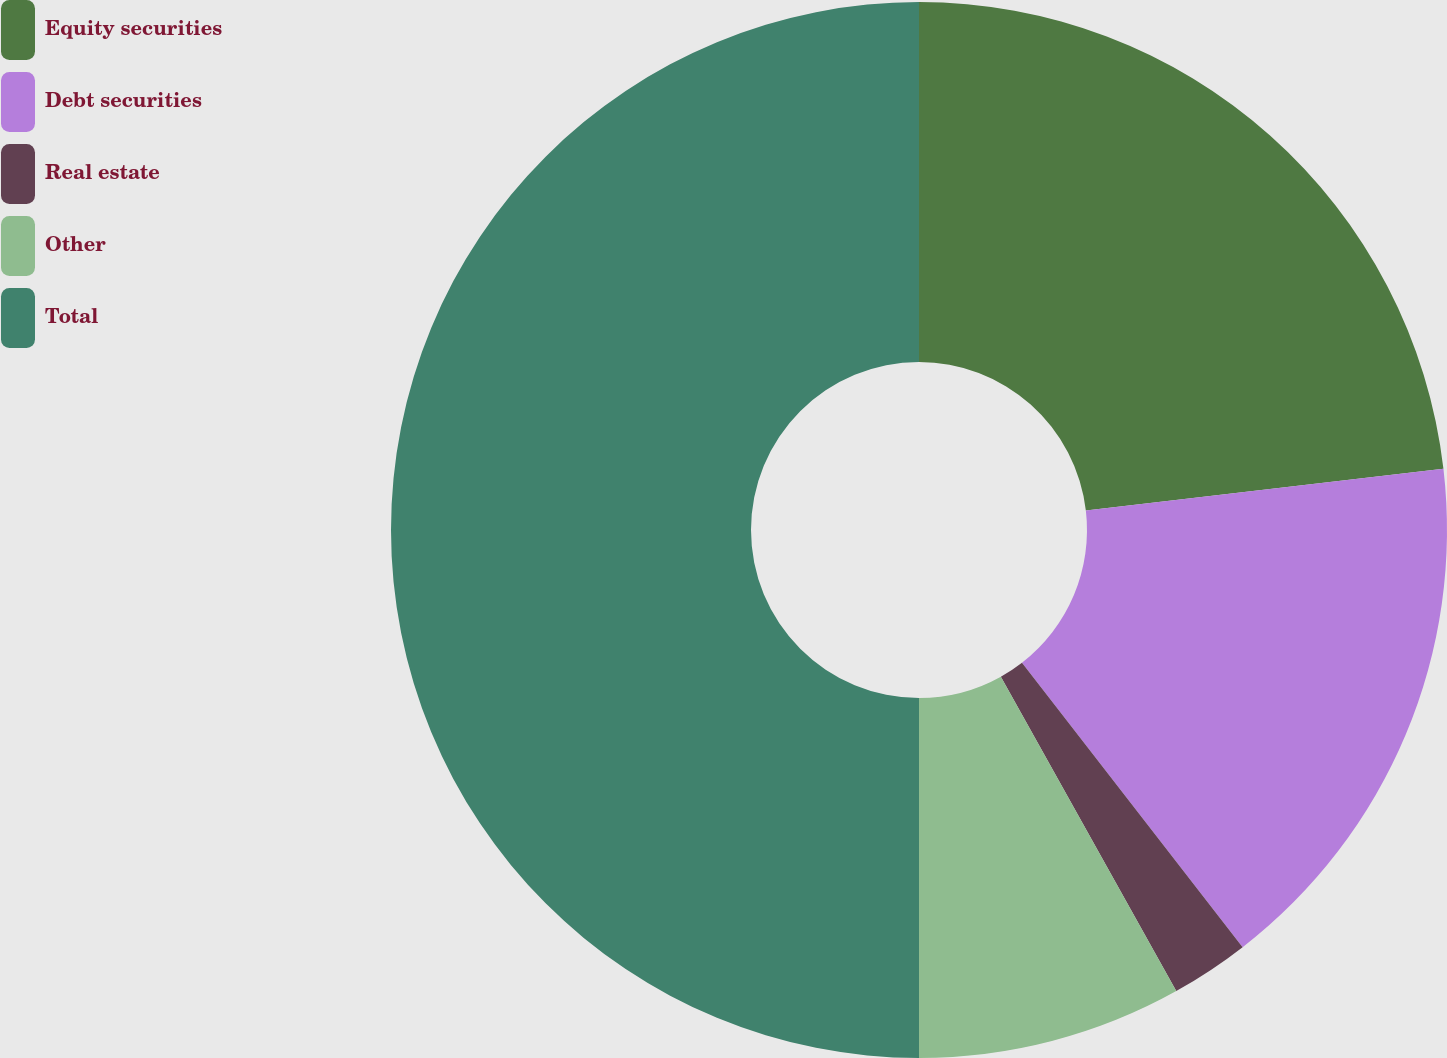Convert chart to OTSL. <chart><loc_0><loc_0><loc_500><loc_500><pie_chart><fcel>Equity securities<fcel>Debt securities<fcel>Real estate<fcel>Other<fcel>Total<nl><fcel>23.15%<fcel>16.35%<fcel>2.4%<fcel>8.1%<fcel>50.0%<nl></chart> 